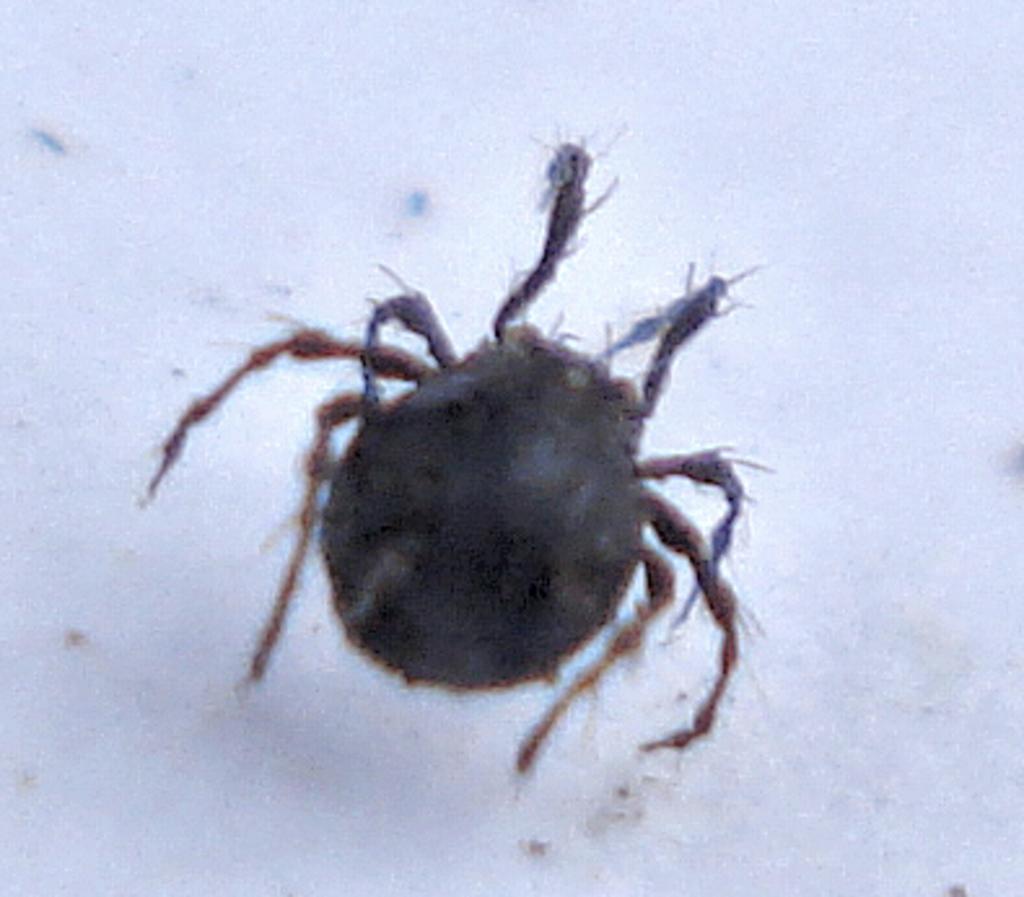Could you give a brief overview of what you see in this image? In this image there is an insect. 